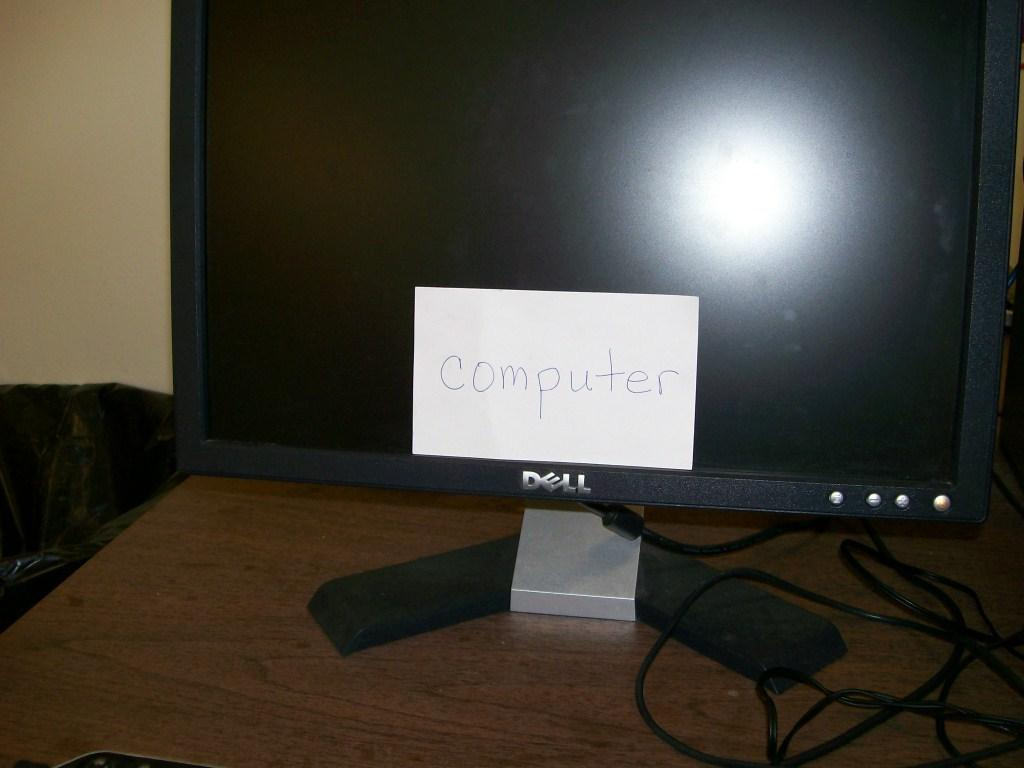Provide a one-sentence caption for the provided image. A Dell computer monitor has a post it on it that reads computer. 